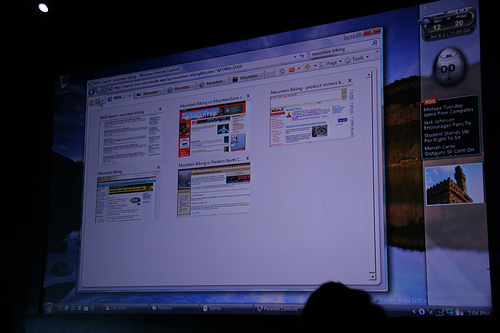<image>
Is the light behind the screen? Yes. From this viewpoint, the light is positioned behind the screen, with the screen partially or fully occluding the light. 